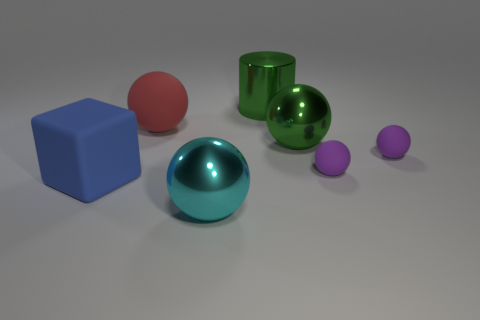Are the green object that is to the right of the large cylinder and the large cylinder made of the same material?
Provide a short and direct response. Yes. Is there anything else that is made of the same material as the large green ball?
Keep it short and to the point. Yes. There is a rubber block that is the same size as the green shiny cylinder; what color is it?
Offer a very short reply. Blue. Is there a big rubber thing that has the same color as the rubber cube?
Make the answer very short. No. What is the size of the red object that is the same material as the block?
Keep it short and to the point. Large. There is a sphere that is the same color as the big cylinder; what size is it?
Keep it short and to the point. Large. How many other things are the same size as the rubber block?
Offer a very short reply. 4. There is a large ball in front of the large blue matte thing; what material is it?
Offer a terse response. Metal. The red rubber thing on the left side of the large metal object in front of the big rubber thing that is in front of the red rubber thing is what shape?
Your answer should be very brief. Sphere. Is the cyan metallic object the same size as the green shiny cylinder?
Make the answer very short. Yes. 